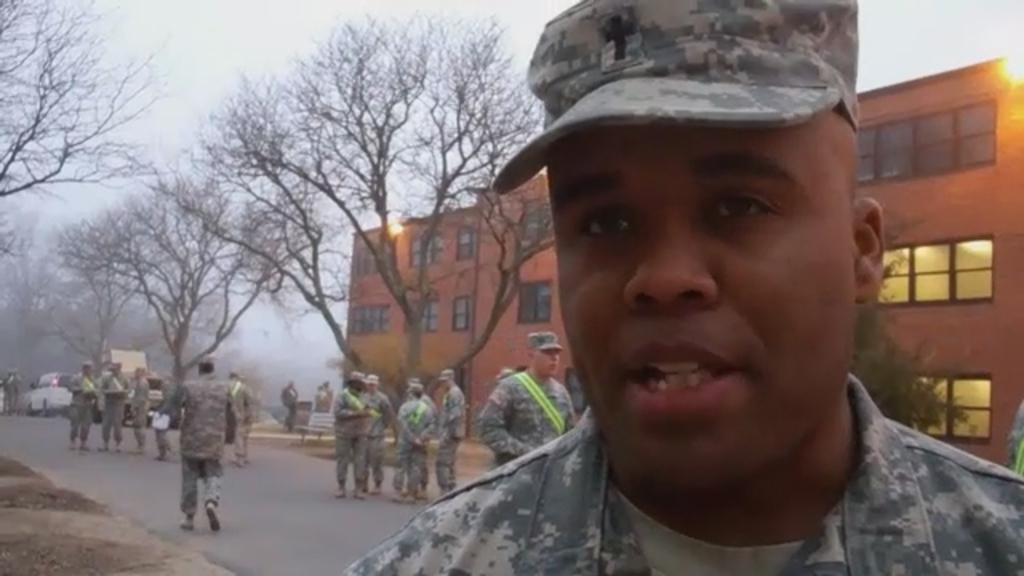Please provide a concise description of this image. In this image we can see a person wearing cap. In the back there is a road. There are many people wearing caps. Also there is a vehicle. And there is a building with windows. There are lights. Also there are trees. And we can see a bench in the background. And it is looking like fog. 